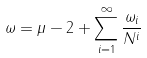Convert formula to latex. <formula><loc_0><loc_0><loc_500><loc_500>\omega = \mu - 2 + \sum _ { i = 1 } ^ { \infty } \frac { \omega _ { i } } { N ^ { i } }</formula> 